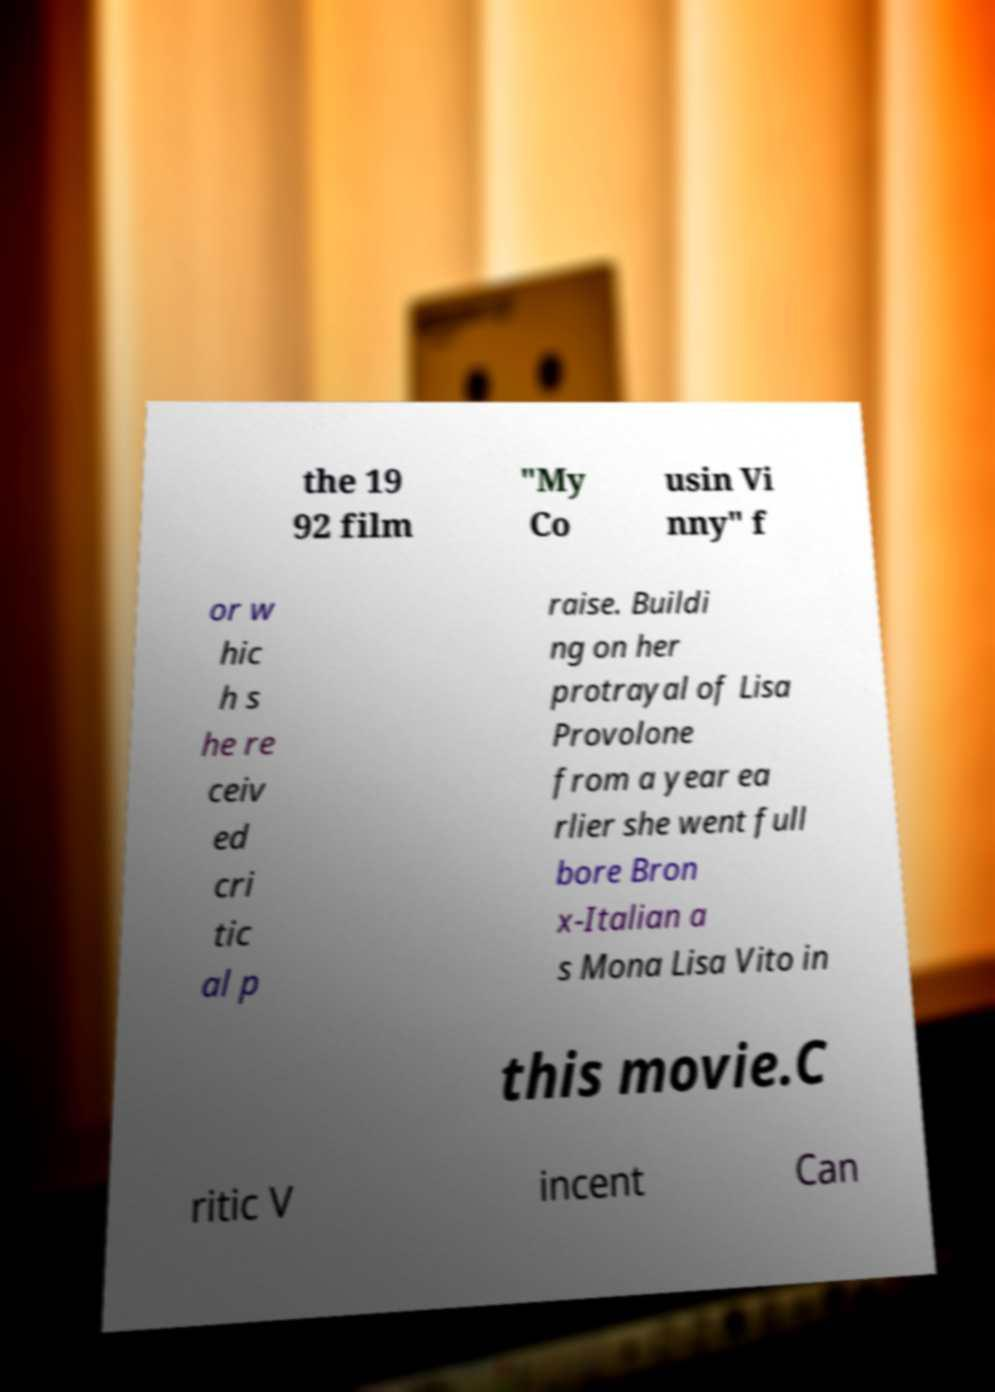For documentation purposes, I need the text within this image transcribed. Could you provide that? the 19 92 film "My Co usin Vi nny" f or w hic h s he re ceiv ed cri tic al p raise. Buildi ng on her protrayal of Lisa Provolone from a year ea rlier she went full bore Bron x-Italian a s Mona Lisa Vito in this movie.C ritic V incent Can 